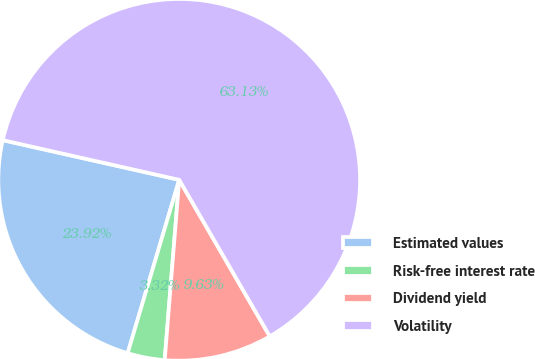Convert chart to OTSL. <chart><loc_0><loc_0><loc_500><loc_500><pie_chart><fcel>Estimated values<fcel>Risk-free interest rate<fcel>Dividend yield<fcel>Volatility<nl><fcel>23.92%<fcel>3.32%<fcel>9.63%<fcel>63.12%<nl></chart> 